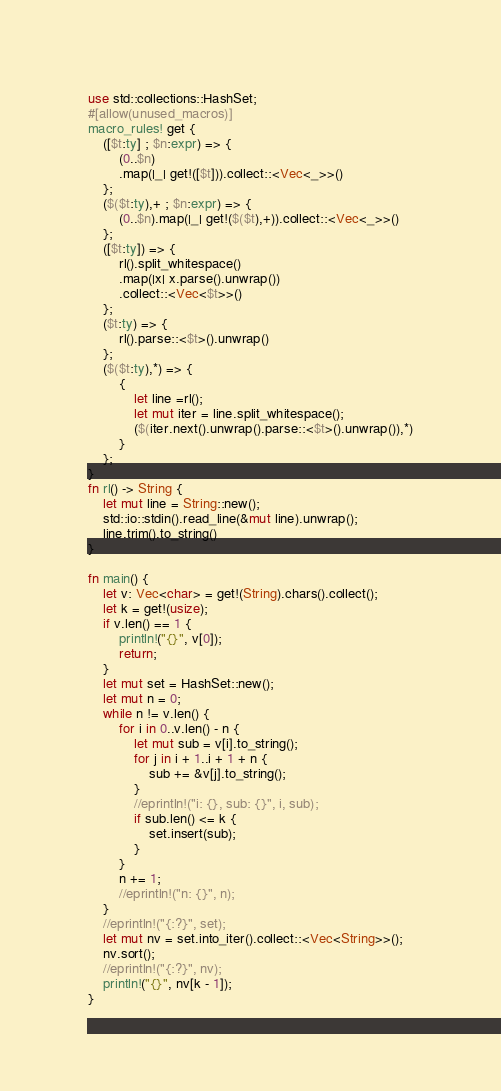<code> <loc_0><loc_0><loc_500><loc_500><_Rust_>use std::collections::HashSet;
#[allow(unused_macros)]
macro_rules! get {
    ([$t:ty] ; $n:expr) => {
        (0..$n)
        .map(|_| get!([$t])).collect::<Vec<_>>()
    };
    ($($t:ty),+ ; $n:expr) => {
        (0..$n).map(|_| get!($($t),+)).collect::<Vec<_>>()
    };
    ([$t:ty]) => {
        rl().split_whitespace()
        .map(|x| x.parse().unwrap())
        .collect::<Vec<$t>>()
    };
    ($t:ty) => {
        rl().parse::<$t>().unwrap()
    };
    ($($t:ty),*) => {
        {
            let line =rl();
            let mut iter = line.split_whitespace();
            ($(iter.next().unwrap().parse::<$t>().unwrap()),*)
        }
    };
}
fn rl() -> String {
    let mut line = String::new();
    std::io::stdin().read_line(&mut line).unwrap();
    line.trim().to_string()
}

fn main() {
    let v: Vec<char> = get!(String).chars().collect();
    let k = get!(usize);
    if v.len() == 1 {
        println!("{}", v[0]);
        return;
    }
    let mut set = HashSet::new();
    let mut n = 0;
    while n != v.len() {
        for i in 0..v.len() - n {
            let mut sub = v[i].to_string();
            for j in i + 1..i + 1 + n {
                sub += &v[j].to_string();
            }
            //eprintln!("i: {}, sub: {}", i, sub);
            if sub.len() <= k {
                set.insert(sub);
            }
        }
        n += 1;
        //eprintln!("n: {}", n);
    }
    //eprintln!("{:?}", set);
    let mut nv = set.into_iter().collect::<Vec<String>>();
    nv.sort();
    //eprintln!("{:?}", nv);
    println!("{}", nv[k - 1]);
}
</code> 